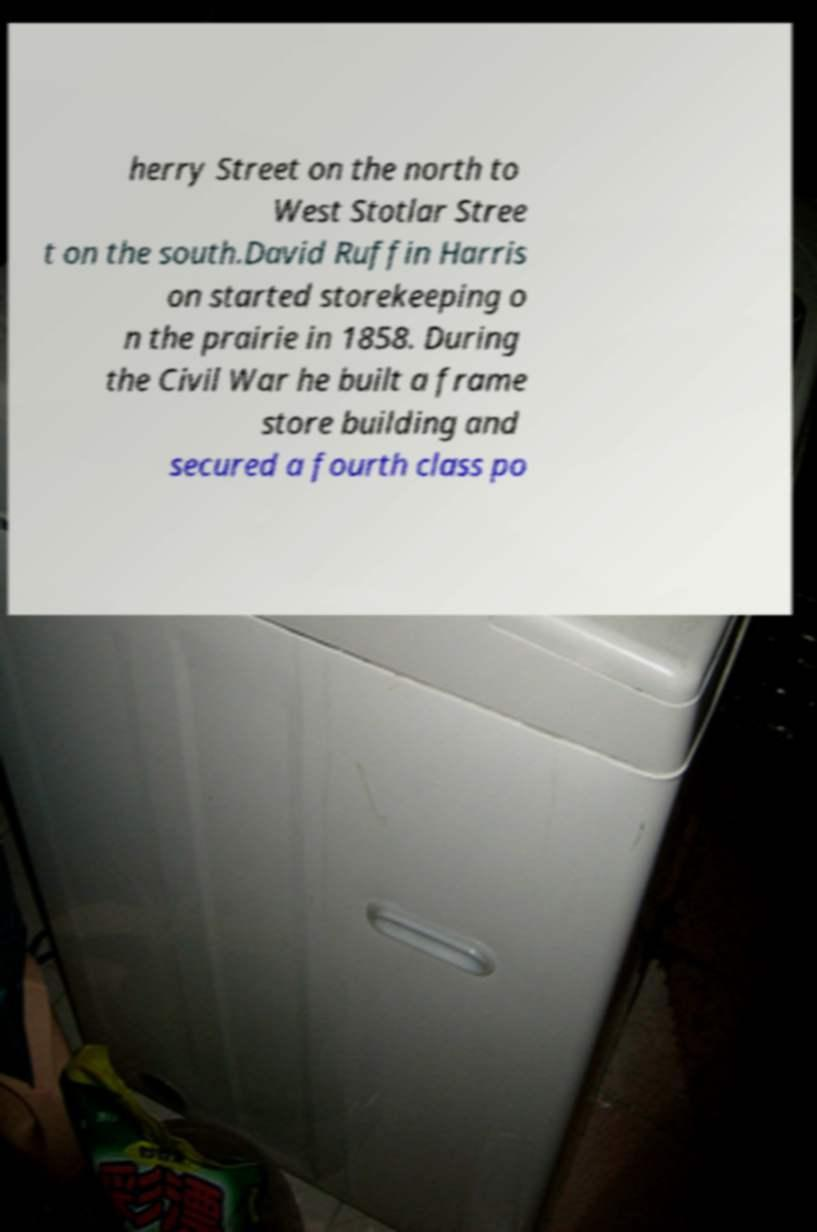There's text embedded in this image that I need extracted. Can you transcribe it verbatim? herry Street on the north to West Stotlar Stree t on the south.David Ruffin Harris on started storekeeping o n the prairie in 1858. During the Civil War he built a frame store building and secured a fourth class po 